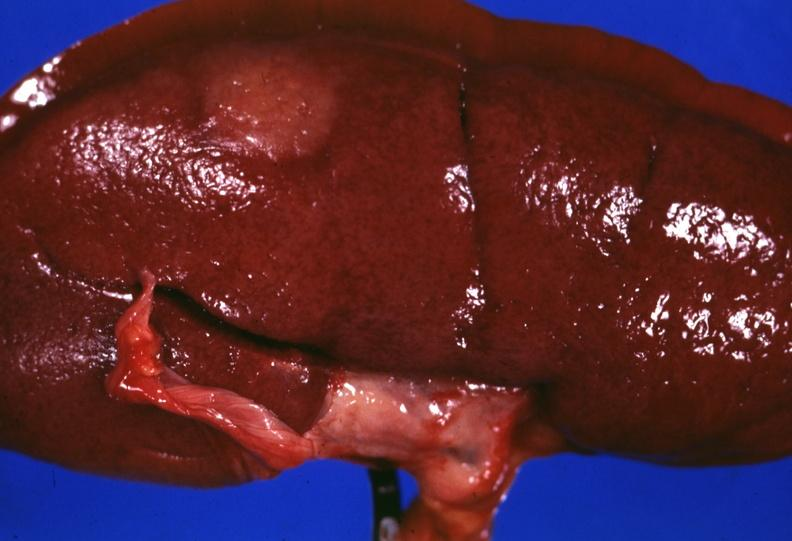s sarcoidosis present?
Answer the question using a single word or phrase. Yes 